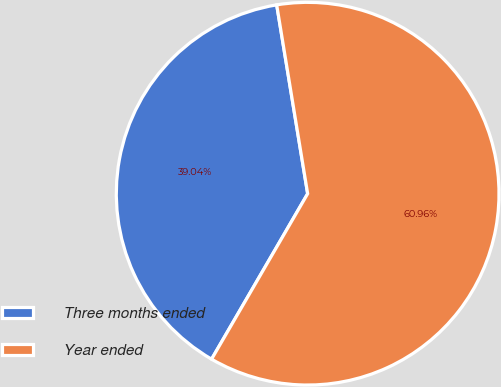Convert chart to OTSL. <chart><loc_0><loc_0><loc_500><loc_500><pie_chart><fcel>Three months ended<fcel>Year ended<nl><fcel>39.04%<fcel>60.96%<nl></chart> 